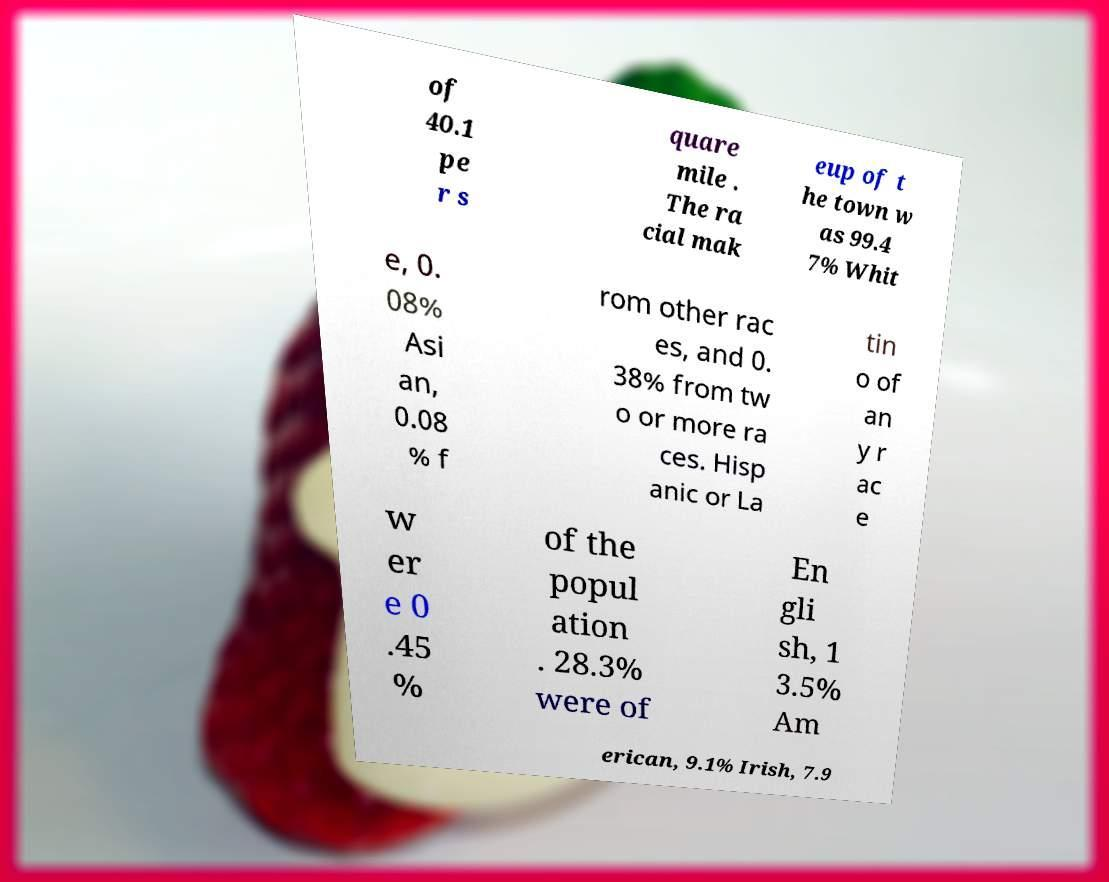Please identify and transcribe the text found in this image. of 40.1 pe r s quare mile . The ra cial mak eup of t he town w as 99.4 7% Whit e, 0. 08% Asi an, 0.08 % f rom other rac es, and 0. 38% from tw o or more ra ces. Hisp anic or La tin o of an y r ac e w er e 0 .45 % of the popul ation . 28.3% were of En gli sh, 1 3.5% Am erican, 9.1% Irish, 7.9 